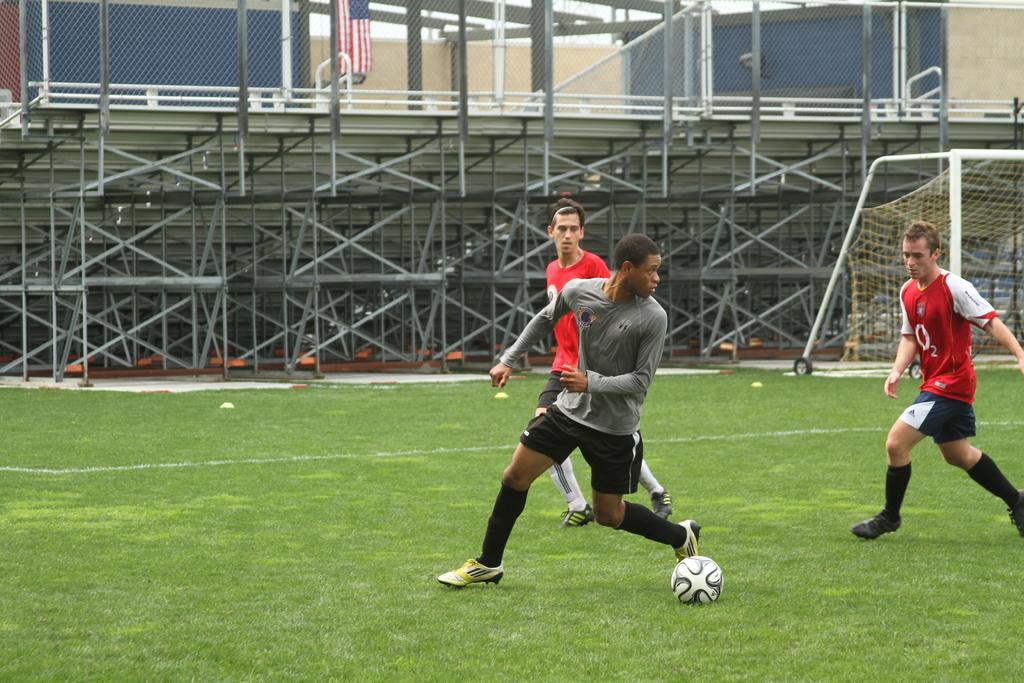Can you describe this image briefly? In this image we can see a three persons in a ground and we can see a ball and the grass. Behind the persons there are group of poles. At the top we can see a fence and a flag. On the right side, we can see a goal post. 